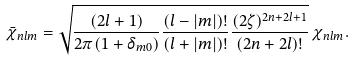<formula> <loc_0><loc_0><loc_500><loc_500>\bar { \chi } _ { n l m } = \sqrt { \frac { ( 2 l + 1 ) } { 2 \pi ( 1 + \delta _ { m 0 } ) } \frac { ( l - | m | ) ! } { ( l + | m | ) ! } \frac { ( 2 \zeta ) ^ { 2 n + 2 l + 1 } } { ( 2 n + 2 l ) ! } } \, \chi _ { n l m } .</formula> 